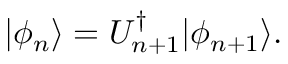Convert formula to latex. <formula><loc_0><loc_0><loc_500><loc_500>| \phi _ { n } \rangle = U _ { n + 1 } ^ { \dagger } | \phi _ { n + 1 } \rangle .</formula> 